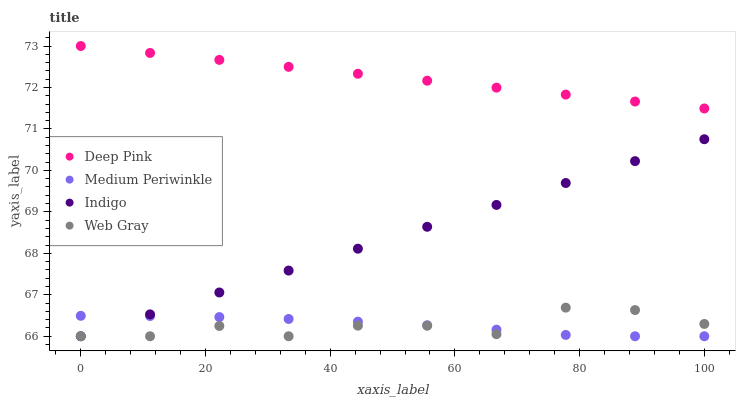Does Web Gray have the minimum area under the curve?
Answer yes or no. Yes. Does Deep Pink have the maximum area under the curve?
Answer yes or no. Yes. Does Indigo have the minimum area under the curve?
Answer yes or no. No. Does Indigo have the maximum area under the curve?
Answer yes or no. No. Is Deep Pink the smoothest?
Answer yes or no. Yes. Is Web Gray the roughest?
Answer yes or no. Yes. Is Indigo the smoothest?
Answer yes or no. No. Is Indigo the roughest?
Answer yes or no. No. Does Web Gray have the lowest value?
Answer yes or no. Yes. Does Deep Pink have the lowest value?
Answer yes or no. No. Does Deep Pink have the highest value?
Answer yes or no. Yes. Does Indigo have the highest value?
Answer yes or no. No. Is Medium Periwinkle less than Deep Pink?
Answer yes or no. Yes. Is Deep Pink greater than Web Gray?
Answer yes or no. Yes. Does Web Gray intersect Medium Periwinkle?
Answer yes or no. Yes. Is Web Gray less than Medium Periwinkle?
Answer yes or no. No. Is Web Gray greater than Medium Periwinkle?
Answer yes or no. No. Does Medium Periwinkle intersect Deep Pink?
Answer yes or no. No. 